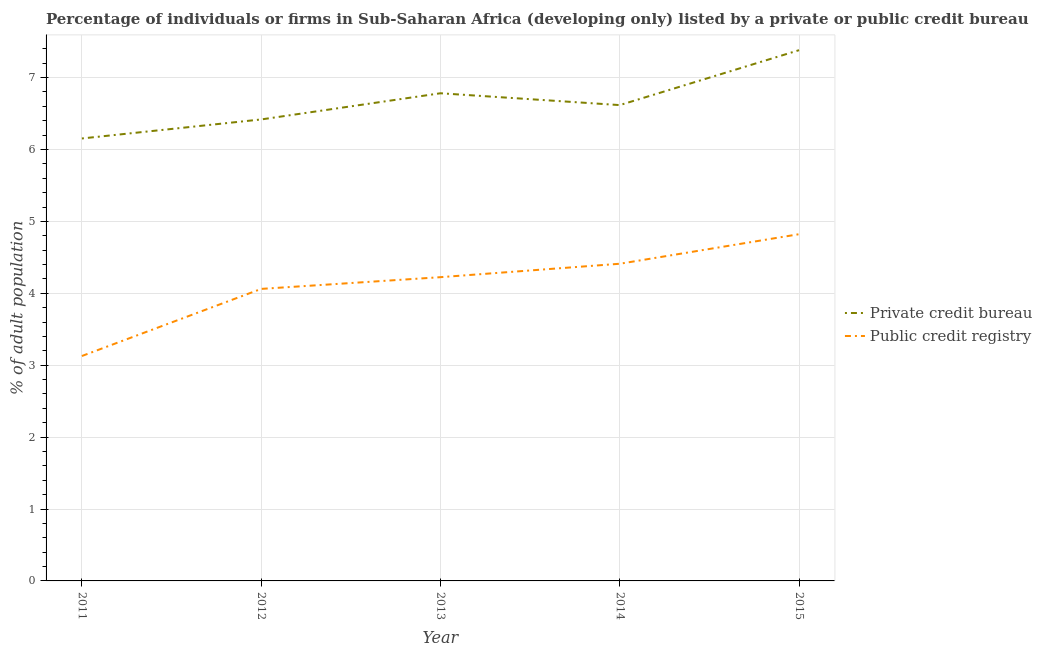What is the percentage of firms listed by public credit bureau in 2015?
Provide a succinct answer. 4.82. Across all years, what is the maximum percentage of firms listed by private credit bureau?
Make the answer very short. 7.38. Across all years, what is the minimum percentage of firms listed by private credit bureau?
Give a very brief answer. 6.15. In which year was the percentage of firms listed by private credit bureau maximum?
Provide a short and direct response. 2015. In which year was the percentage of firms listed by private credit bureau minimum?
Your answer should be compact. 2011. What is the total percentage of firms listed by public credit bureau in the graph?
Offer a terse response. 20.65. What is the difference between the percentage of firms listed by private credit bureau in 2012 and that in 2013?
Keep it short and to the point. -0.36. What is the difference between the percentage of firms listed by public credit bureau in 2013 and the percentage of firms listed by private credit bureau in 2014?
Your answer should be compact. -2.39. What is the average percentage of firms listed by private credit bureau per year?
Your answer should be compact. 6.67. In the year 2012, what is the difference between the percentage of firms listed by public credit bureau and percentage of firms listed by private credit bureau?
Provide a succinct answer. -2.36. In how many years, is the percentage of firms listed by private credit bureau greater than 4 %?
Your answer should be compact. 5. What is the ratio of the percentage of firms listed by private credit bureau in 2011 to that in 2012?
Offer a terse response. 0.96. What is the difference between the highest and the second highest percentage of firms listed by private credit bureau?
Your answer should be compact. 0.6. What is the difference between the highest and the lowest percentage of firms listed by private credit bureau?
Give a very brief answer. 1.23. In how many years, is the percentage of firms listed by private credit bureau greater than the average percentage of firms listed by private credit bureau taken over all years?
Your answer should be very brief. 2. Does the percentage of firms listed by public credit bureau monotonically increase over the years?
Provide a short and direct response. Yes. Is the percentage of firms listed by public credit bureau strictly greater than the percentage of firms listed by private credit bureau over the years?
Offer a very short reply. No. Are the values on the major ticks of Y-axis written in scientific E-notation?
Make the answer very short. No. Does the graph contain any zero values?
Keep it short and to the point. No. Where does the legend appear in the graph?
Your response must be concise. Center right. How many legend labels are there?
Ensure brevity in your answer.  2. How are the legend labels stacked?
Your answer should be very brief. Vertical. What is the title of the graph?
Make the answer very short. Percentage of individuals or firms in Sub-Saharan Africa (developing only) listed by a private or public credit bureau. What is the label or title of the Y-axis?
Ensure brevity in your answer.  % of adult population. What is the % of adult population of Private credit bureau in 2011?
Ensure brevity in your answer.  6.15. What is the % of adult population of Public credit registry in 2011?
Ensure brevity in your answer.  3.13. What is the % of adult population of Private credit bureau in 2012?
Provide a short and direct response. 6.42. What is the % of adult population in Public credit registry in 2012?
Provide a succinct answer. 4.06. What is the % of adult population in Private credit bureau in 2013?
Provide a short and direct response. 6.78. What is the % of adult population of Public credit registry in 2013?
Offer a very short reply. 4.22. What is the % of adult population of Private credit bureau in 2014?
Provide a succinct answer. 6.62. What is the % of adult population in Public credit registry in 2014?
Keep it short and to the point. 4.41. What is the % of adult population of Private credit bureau in 2015?
Your answer should be very brief. 7.38. What is the % of adult population in Public credit registry in 2015?
Offer a terse response. 4.82. Across all years, what is the maximum % of adult population of Private credit bureau?
Give a very brief answer. 7.38. Across all years, what is the maximum % of adult population of Public credit registry?
Offer a terse response. 4.82. Across all years, what is the minimum % of adult population in Private credit bureau?
Your answer should be very brief. 6.15. Across all years, what is the minimum % of adult population in Public credit registry?
Your response must be concise. 3.13. What is the total % of adult population in Private credit bureau in the graph?
Give a very brief answer. 33.35. What is the total % of adult population of Public credit registry in the graph?
Keep it short and to the point. 20.65. What is the difference between the % of adult population in Private credit bureau in 2011 and that in 2012?
Your response must be concise. -0.26. What is the difference between the % of adult population of Public credit registry in 2011 and that in 2012?
Your answer should be compact. -0.93. What is the difference between the % of adult population of Private credit bureau in 2011 and that in 2013?
Your answer should be compact. -0.63. What is the difference between the % of adult population of Public credit registry in 2011 and that in 2013?
Your answer should be very brief. -1.1. What is the difference between the % of adult population of Private credit bureau in 2011 and that in 2014?
Offer a terse response. -0.46. What is the difference between the % of adult population of Public credit registry in 2011 and that in 2014?
Offer a very short reply. -1.28. What is the difference between the % of adult population in Private credit bureau in 2011 and that in 2015?
Offer a very short reply. -1.23. What is the difference between the % of adult population in Public credit registry in 2011 and that in 2015?
Your answer should be compact. -1.69. What is the difference between the % of adult population of Private credit bureau in 2012 and that in 2013?
Offer a very short reply. -0.36. What is the difference between the % of adult population of Public credit registry in 2012 and that in 2013?
Make the answer very short. -0.16. What is the difference between the % of adult population in Private credit bureau in 2012 and that in 2014?
Ensure brevity in your answer.  -0.2. What is the difference between the % of adult population of Public credit registry in 2012 and that in 2014?
Your answer should be very brief. -0.35. What is the difference between the % of adult population of Private credit bureau in 2012 and that in 2015?
Your answer should be compact. -0.96. What is the difference between the % of adult population of Public credit registry in 2012 and that in 2015?
Make the answer very short. -0.76. What is the difference between the % of adult population of Private credit bureau in 2013 and that in 2014?
Your response must be concise. 0.16. What is the difference between the % of adult population in Public credit registry in 2013 and that in 2014?
Your response must be concise. -0.19. What is the difference between the % of adult population of Private credit bureau in 2013 and that in 2015?
Ensure brevity in your answer.  -0.6. What is the difference between the % of adult population of Public credit registry in 2013 and that in 2015?
Ensure brevity in your answer.  -0.6. What is the difference between the % of adult population of Private credit bureau in 2014 and that in 2015?
Ensure brevity in your answer.  -0.76. What is the difference between the % of adult population of Public credit registry in 2014 and that in 2015?
Ensure brevity in your answer.  -0.41. What is the difference between the % of adult population in Private credit bureau in 2011 and the % of adult population in Public credit registry in 2012?
Give a very brief answer. 2.09. What is the difference between the % of adult population in Private credit bureau in 2011 and the % of adult population in Public credit registry in 2013?
Your answer should be very brief. 1.93. What is the difference between the % of adult population in Private credit bureau in 2011 and the % of adult population in Public credit registry in 2014?
Offer a very short reply. 1.74. What is the difference between the % of adult population of Private credit bureau in 2011 and the % of adult population of Public credit registry in 2015?
Make the answer very short. 1.33. What is the difference between the % of adult population in Private credit bureau in 2012 and the % of adult population in Public credit registry in 2013?
Give a very brief answer. 2.19. What is the difference between the % of adult population of Private credit bureau in 2012 and the % of adult population of Public credit registry in 2014?
Make the answer very short. 2.01. What is the difference between the % of adult population in Private credit bureau in 2012 and the % of adult population in Public credit registry in 2015?
Your answer should be compact. 1.6. What is the difference between the % of adult population of Private credit bureau in 2013 and the % of adult population of Public credit registry in 2014?
Your answer should be compact. 2.37. What is the difference between the % of adult population of Private credit bureau in 2013 and the % of adult population of Public credit registry in 2015?
Offer a very short reply. 1.96. What is the difference between the % of adult population of Private credit bureau in 2014 and the % of adult population of Public credit registry in 2015?
Keep it short and to the point. 1.8. What is the average % of adult population in Private credit bureau per year?
Provide a short and direct response. 6.67. What is the average % of adult population of Public credit registry per year?
Offer a very short reply. 4.13. In the year 2011, what is the difference between the % of adult population of Private credit bureau and % of adult population of Public credit registry?
Your answer should be compact. 3.03. In the year 2012, what is the difference between the % of adult population in Private credit bureau and % of adult population in Public credit registry?
Your answer should be compact. 2.36. In the year 2013, what is the difference between the % of adult population in Private credit bureau and % of adult population in Public credit registry?
Make the answer very short. 2.56. In the year 2014, what is the difference between the % of adult population in Private credit bureau and % of adult population in Public credit registry?
Your response must be concise. 2.21. In the year 2015, what is the difference between the % of adult population in Private credit bureau and % of adult population in Public credit registry?
Provide a succinct answer. 2.56. What is the ratio of the % of adult population of Private credit bureau in 2011 to that in 2012?
Give a very brief answer. 0.96. What is the ratio of the % of adult population of Public credit registry in 2011 to that in 2012?
Offer a very short reply. 0.77. What is the ratio of the % of adult population in Private credit bureau in 2011 to that in 2013?
Your answer should be very brief. 0.91. What is the ratio of the % of adult population of Public credit registry in 2011 to that in 2013?
Your response must be concise. 0.74. What is the ratio of the % of adult population of Private credit bureau in 2011 to that in 2014?
Give a very brief answer. 0.93. What is the ratio of the % of adult population in Public credit registry in 2011 to that in 2014?
Offer a very short reply. 0.71. What is the ratio of the % of adult population in Private credit bureau in 2011 to that in 2015?
Provide a short and direct response. 0.83. What is the ratio of the % of adult population of Public credit registry in 2011 to that in 2015?
Give a very brief answer. 0.65. What is the ratio of the % of adult population in Private credit bureau in 2012 to that in 2013?
Provide a succinct answer. 0.95. What is the ratio of the % of adult population of Public credit registry in 2012 to that in 2013?
Give a very brief answer. 0.96. What is the ratio of the % of adult population in Private credit bureau in 2012 to that in 2014?
Your answer should be compact. 0.97. What is the ratio of the % of adult population of Public credit registry in 2012 to that in 2014?
Your answer should be compact. 0.92. What is the ratio of the % of adult population of Private credit bureau in 2012 to that in 2015?
Provide a short and direct response. 0.87. What is the ratio of the % of adult population of Public credit registry in 2012 to that in 2015?
Give a very brief answer. 0.84. What is the ratio of the % of adult population in Private credit bureau in 2013 to that in 2014?
Provide a short and direct response. 1.02. What is the ratio of the % of adult population in Public credit registry in 2013 to that in 2014?
Ensure brevity in your answer.  0.96. What is the ratio of the % of adult population in Private credit bureau in 2013 to that in 2015?
Make the answer very short. 0.92. What is the ratio of the % of adult population of Public credit registry in 2013 to that in 2015?
Make the answer very short. 0.88. What is the ratio of the % of adult population of Private credit bureau in 2014 to that in 2015?
Your answer should be compact. 0.9. What is the ratio of the % of adult population in Public credit registry in 2014 to that in 2015?
Your answer should be compact. 0.91. What is the difference between the highest and the second highest % of adult population in Private credit bureau?
Your answer should be very brief. 0.6. What is the difference between the highest and the second highest % of adult population of Public credit registry?
Your answer should be very brief. 0.41. What is the difference between the highest and the lowest % of adult population of Private credit bureau?
Ensure brevity in your answer.  1.23. What is the difference between the highest and the lowest % of adult population of Public credit registry?
Offer a very short reply. 1.69. 